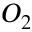<formula> <loc_0><loc_0><loc_500><loc_500>O _ { 2 }</formula> 